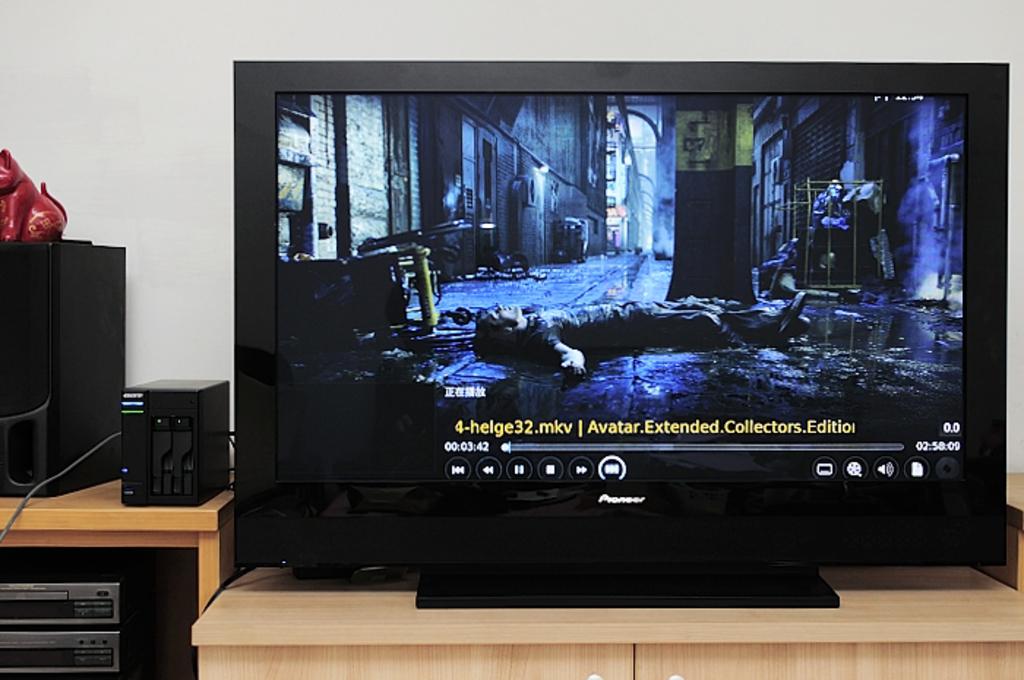How far into the movie are they?
Ensure brevity in your answer.  3:42. Are they watching avatar?
Give a very brief answer. Yes. 